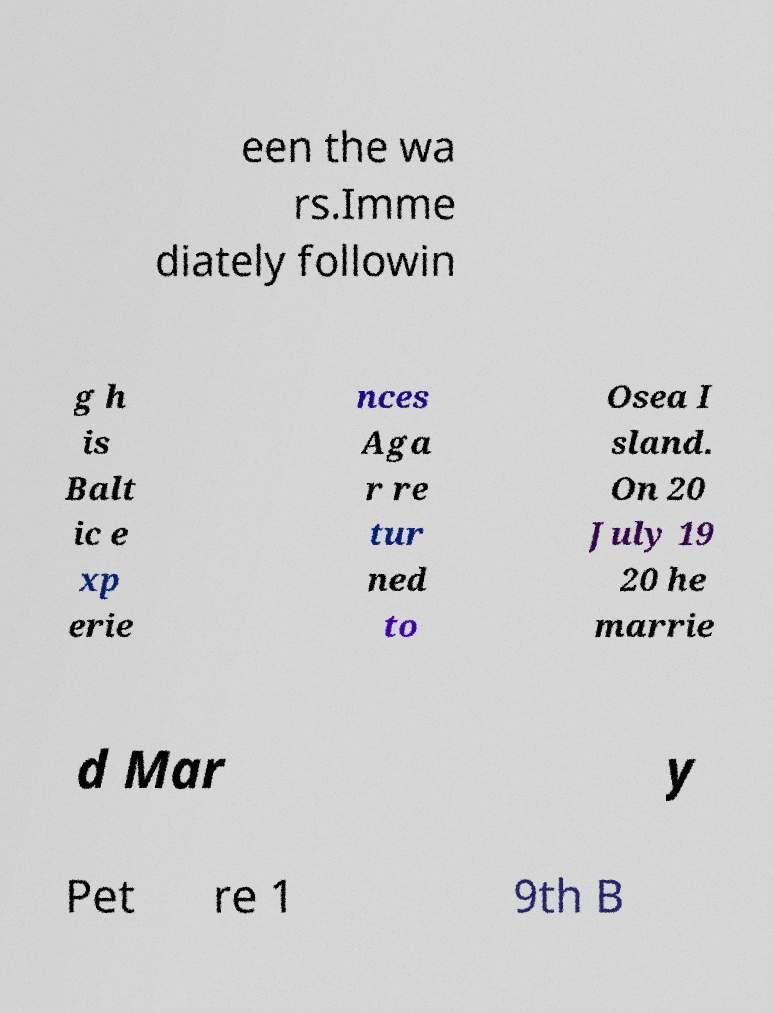For documentation purposes, I need the text within this image transcribed. Could you provide that? een the wa rs.Imme diately followin g h is Balt ic e xp erie nces Aga r re tur ned to Osea I sland. On 20 July 19 20 he marrie d Mar y Pet re 1 9th B 